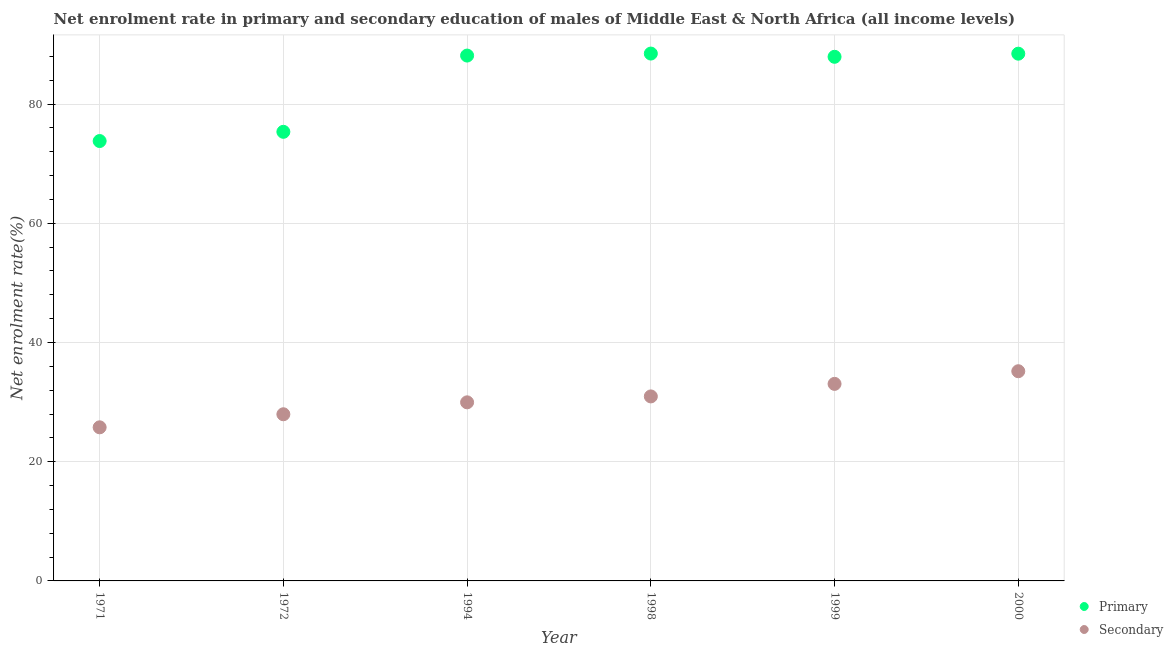What is the enrollment rate in secondary education in 1994?
Ensure brevity in your answer.  29.96. Across all years, what is the maximum enrollment rate in primary education?
Give a very brief answer. 88.48. Across all years, what is the minimum enrollment rate in secondary education?
Give a very brief answer. 25.77. In which year was the enrollment rate in secondary education maximum?
Your answer should be compact. 2000. What is the total enrollment rate in secondary education in the graph?
Your answer should be very brief. 182.89. What is the difference between the enrollment rate in secondary education in 1972 and that in 1998?
Provide a succinct answer. -2.99. What is the difference between the enrollment rate in primary education in 1994 and the enrollment rate in secondary education in 1998?
Offer a very short reply. 57.19. What is the average enrollment rate in secondary education per year?
Your answer should be compact. 30.48. In the year 2000, what is the difference between the enrollment rate in primary education and enrollment rate in secondary education?
Give a very brief answer. 53.27. What is the ratio of the enrollment rate in primary education in 1994 to that in 1998?
Your response must be concise. 1. Is the enrollment rate in primary education in 1971 less than that in 1999?
Ensure brevity in your answer.  Yes. What is the difference between the highest and the second highest enrollment rate in primary education?
Your answer should be very brief. 0.02. What is the difference between the highest and the lowest enrollment rate in primary education?
Offer a very short reply. 14.68. Is the enrollment rate in primary education strictly less than the enrollment rate in secondary education over the years?
Give a very brief answer. No. How many years are there in the graph?
Offer a terse response. 6. Does the graph contain any zero values?
Provide a succinct answer. No. Does the graph contain grids?
Your response must be concise. Yes. How are the legend labels stacked?
Give a very brief answer. Vertical. What is the title of the graph?
Your answer should be compact. Net enrolment rate in primary and secondary education of males of Middle East & North Africa (all income levels). What is the label or title of the Y-axis?
Give a very brief answer. Net enrolment rate(%). What is the Net enrolment rate(%) in Primary in 1971?
Offer a terse response. 73.8. What is the Net enrolment rate(%) of Secondary in 1971?
Offer a very short reply. 25.77. What is the Net enrolment rate(%) in Primary in 1972?
Ensure brevity in your answer.  75.35. What is the Net enrolment rate(%) of Secondary in 1972?
Give a very brief answer. 27.96. What is the Net enrolment rate(%) of Primary in 1994?
Make the answer very short. 88.14. What is the Net enrolment rate(%) of Secondary in 1994?
Provide a short and direct response. 29.96. What is the Net enrolment rate(%) in Primary in 1998?
Your answer should be very brief. 88.48. What is the Net enrolment rate(%) in Secondary in 1998?
Keep it short and to the point. 30.95. What is the Net enrolment rate(%) in Primary in 1999?
Keep it short and to the point. 87.93. What is the Net enrolment rate(%) in Secondary in 1999?
Your answer should be compact. 33.06. What is the Net enrolment rate(%) in Primary in 2000?
Make the answer very short. 88.46. What is the Net enrolment rate(%) in Secondary in 2000?
Your answer should be compact. 35.18. Across all years, what is the maximum Net enrolment rate(%) in Primary?
Offer a very short reply. 88.48. Across all years, what is the maximum Net enrolment rate(%) in Secondary?
Your answer should be compact. 35.18. Across all years, what is the minimum Net enrolment rate(%) in Primary?
Ensure brevity in your answer.  73.8. Across all years, what is the minimum Net enrolment rate(%) in Secondary?
Offer a very short reply. 25.77. What is the total Net enrolment rate(%) in Primary in the graph?
Offer a terse response. 502.16. What is the total Net enrolment rate(%) in Secondary in the graph?
Give a very brief answer. 182.89. What is the difference between the Net enrolment rate(%) in Primary in 1971 and that in 1972?
Offer a very short reply. -1.55. What is the difference between the Net enrolment rate(%) of Secondary in 1971 and that in 1972?
Offer a terse response. -2.19. What is the difference between the Net enrolment rate(%) of Primary in 1971 and that in 1994?
Your response must be concise. -14.34. What is the difference between the Net enrolment rate(%) in Secondary in 1971 and that in 1994?
Keep it short and to the point. -4.19. What is the difference between the Net enrolment rate(%) of Primary in 1971 and that in 1998?
Make the answer very short. -14.68. What is the difference between the Net enrolment rate(%) in Secondary in 1971 and that in 1998?
Provide a short and direct response. -5.18. What is the difference between the Net enrolment rate(%) in Primary in 1971 and that in 1999?
Ensure brevity in your answer.  -14.13. What is the difference between the Net enrolment rate(%) of Secondary in 1971 and that in 1999?
Your response must be concise. -7.29. What is the difference between the Net enrolment rate(%) of Primary in 1971 and that in 2000?
Give a very brief answer. -14.66. What is the difference between the Net enrolment rate(%) in Secondary in 1971 and that in 2000?
Provide a succinct answer. -9.41. What is the difference between the Net enrolment rate(%) of Primary in 1972 and that in 1994?
Ensure brevity in your answer.  -12.79. What is the difference between the Net enrolment rate(%) in Secondary in 1972 and that in 1994?
Your response must be concise. -2. What is the difference between the Net enrolment rate(%) of Primary in 1972 and that in 1998?
Provide a succinct answer. -13.13. What is the difference between the Net enrolment rate(%) of Secondary in 1972 and that in 1998?
Your answer should be compact. -2.99. What is the difference between the Net enrolment rate(%) in Primary in 1972 and that in 1999?
Provide a succinct answer. -12.59. What is the difference between the Net enrolment rate(%) of Secondary in 1972 and that in 1999?
Offer a very short reply. -5.1. What is the difference between the Net enrolment rate(%) of Primary in 1972 and that in 2000?
Make the answer very short. -13.11. What is the difference between the Net enrolment rate(%) in Secondary in 1972 and that in 2000?
Provide a succinct answer. -7.22. What is the difference between the Net enrolment rate(%) in Primary in 1994 and that in 1998?
Provide a succinct answer. -0.34. What is the difference between the Net enrolment rate(%) in Secondary in 1994 and that in 1998?
Make the answer very short. -0.99. What is the difference between the Net enrolment rate(%) of Primary in 1994 and that in 1999?
Provide a short and direct response. 0.21. What is the difference between the Net enrolment rate(%) in Secondary in 1994 and that in 1999?
Your response must be concise. -3.1. What is the difference between the Net enrolment rate(%) of Primary in 1994 and that in 2000?
Offer a very short reply. -0.32. What is the difference between the Net enrolment rate(%) in Secondary in 1994 and that in 2000?
Offer a terse response. -5.22. What is the difference between the Net enrolment rate(%) in Primary in 1998 and that in 1999?
Make the answer very short. 0.54. What is the difference between the Net enrolment rate(%) of Secondary in 1998 and that in 1999?
Make the answer very short. -2.1. What is the difference between the Net enrolment rate(%) of Primary in 1998 and that in 2000?
Offer a very short reply. 0.02. What is the difference between the Net enrolment rate(%) of Secondary in 1998 and that in 2000?
Ensure brevity in your answer.  -4.23. What is the difference between the Net enrolment rate(%) in Primary in 1999 and that in 2000?
Provide a succinct answer. -0.52. What is the difference between the Net enrolment rate(%) in Secondary in 1999 and that in 2000?
Give a very brief answer. -2.12. What is the difference between the Net enrolment rate(%) of Primary in 1971 and the Net enrolment rate(%) of Secondary in 1972?
Provide a succinct answer. 45.84. What is the difference between the Net enrolment rate(%) of Primary in 1971 and the Net enrolment rate(%) of Secondary in 1994?
Your response must be concise. 43.84. What is the difference between the Net enrolment rate(%) in Primary in 1971 and the Net enrolment rate(%) in Secondary in 1998?
Ensure brevity in your answer.  42.85. What is the difference between the Net enrolment rate(%) of Primary in 1971 and the Net enrolment rate(%) of Secondary in 1999?
Provide a short and direct response. 40.74. What is the difference between the Net enrolment rate(%) of Primary in 1971 and the Net enrolment rate(%) of Secondary in 2000?
Ensure brevity in your answer.  38.62. What is the difference between the Net enrolment rate(%) of Primary in 1972 and the Net enrolment rate(%) of Secondary in 1994?
Give a very brief answer. 45.38. What is the difference between the Net enrolment rate(%) in Primary in 1972 and the Net enrolment rate(%) in Secondary in 1998?
Make the answer very short. 44.39. What is the difference between the Net enrolment rate(%) in Primary in 1972 and the Net enrolment rate(%) in Secondary in 1999?
Keep it short and to the point. 42.29. What is the difference between the Net enrolment rate(%) in Primary in 1972 and the Net enrolment rate(%) in Secondary in 2000?
Your answer should be compact. 40.16. What is the difference between the Net enrolment rate(%) of Primary in 1994 and the Net enrolment rate(%) of Secondary in 1998?
Your response must be concise. 57.19. What is the difference between the Net enrolment rate(%) of Primary in 1994 and the Net enrolment rate(%) of Secondary in 1999?
Your answer should be compact. 55.08. What is the difference between the Net enrolment rate(%) in Primary in 1994 and the Net enrolment rate(%) in Secondary in 2000?
Give a very brief answer. 52.96. What is the difference between the Net enrolment rate(%) in Primary in 1998 and the Net enrolment rate(%) in Secondary in 1999?
Provide a succinct answer. 55.42. What is the difference between the Net enrolment rate(%) in Primary in 1998 and the Net enrolment rate(%) in Secondary in 2000?
Keep it short and to the point. 53.29. What is the difference between the Net enrolment rate(%) of Primary in 1999 and the Net enrolment rate(%) of Secondary in 2000?
Offer a terse response. 52.75. What is the average Net enrolment rate(%) of Primary per year?
Provide a short and direct response. 83.69. What is the average Net enrolment rate(%) of Secondary per year?
Your answer should be very brief. 30.48. In the year 1971, what is the difference between the Net enrolment rate(%) in Primary and Net enrolment rate(%) in Secondary?
Offer a terse response. 48.03. In the year 1972, what is the difference between the Net enrolment rate(%) of Primary and Net enrolment rate(%) of Secondary?
Provide a short and direct response. 47.39. In the year 1994, what is the difference between the Net enrolment rate(%) of Primary and Net enrolment rate(%) of Secondary?
Offer a terse response. 58.18. In the year 1998, what is the difference between the Net enrolment rate(%) in Primary and Net enrolment rate(%) in Secondary?
Your response must be concise. 57.52. In the year 1999, what is the difference between the Net enrolment rate(%) of Primary and Net enrolment rate(%) of Secondary?
Offer a very short reply. 54.88. In the year 2000, what is the difference between the Net enrolment rate(%) in Primary and Net enrolment rate(%) in Secondary?
Make the answer very short. 53.27. What is the ratio of the Net enrolment rate(%) of Primary in 1971 to that in 1972?
Make the answer very short. 0.98. What is the ratio of the Net enrolment rate(%) in Secondary in 1971 to that in 1972?
Your response must be concise. 0.92. What is the ratio of the Net enrolment rate(%) of Primary in 1971 to that in 1994?
Your response must be concise. 0.84. What is the ratio of the Net enrolment rate(%) in Secondary in 1971 to that in 1994?
Offer a terse response. 0.86. What is the ratio of the Net enrolment rate(%) of Primary in 1971 to that in 1998?
Give a very brief answer. 0.83. What is the ratio of the Net enrolment rate(%) of Secondary in 1971 to that in 1998?
Keep it short and to the point. 0.83. What is the ratio of the Net enrolment rate(%) of Primary in 1971 to that in 1999?
Offer a very short reply. 0.84. What is the ratio of the Net enrolment rate(%) of Secondary in 1971 to that in 1999?
Ensure brevity in your answer.  0.78. What is the ratio of the Net enrolment rate(%) of Primary in 1971 to that in 2000?
Provide a succinct answer. 0.83. What is the ratio of the Net enrolment rate(%) of Secondary in 1971 to that in 2000?
Ensure brevity in your answer.  0.73. What is the ratio of the Net enrolment rate(%) of Primary in 1972 to that in 1994?
Provide a short and direct response. 0.85. What is the ratio of the Net enrolment rate(%) in Secondary in 1972 to that in 1994?
Ensure brevity in your answer.  0.93. What is the ratio of the Net enrolment rate(%) in Primary in 1972 to that in 1998?
Provide a succinct answer. 0.85. What is the ratio of the Net enrolment rate(%) of Secondary in 1972 to that in 1998?
Ensure brevity in your answer.  0.9. What is the ratio of the Net enrolment rate(%) in Primary in 1972 to that in 1999?
Your response must be concise. 0.86. What is the ratio of the Net enrolment rate(%) in Secondary in 1972 to that in 1999?
Provide a succinct answer. 0.85. What is the ratio of the Net enrolment rate(%) of Primary in 1972 to that in 2000?
Give a very brief answer. 0.85. What is the ratio of the Net enrolment rate(%) in Secondary in 1972 to that in 2000?
Your answer should be very brief. 0.79. What is the ratio of the Net enrolment rate(%) in Primary in 1994 to that in 1998?
Make the answer very short. 1. What is the ratio of the Net enrolment rate(%) of Primary in 1994 to that in 1999?
Your response must be concise. 1. What is the ratio of the Net enrolment rate(%) of Secondary in 1994 to that in 1999?
Give a very brief answer. 0.91. What is the ratio of the Net enrolment rate(%) in Primary in 1994 to that in 2000?
Keep it short and to the point. 1. What is the ratio of the Net enrolment rate(%) of Secondary in 1994 to that in 2000?
Offer a terse response. 0.85. What is the ratio of the Net enrolment rate(%) of Secondary in 1998 to that in 1999?
Provide a short and direct response. 0.94. What is the ratio of the Net enrolment rate(%) of Secondary in 1998 to that in 2000?
Offer a terse response. 0.88. What is the ratio of the Net enrolment rate(%) of Primary in 1999 to that in 2000?
Offer a very short reply. 0.99. What is the ratio of the Net enrolment rate(%) of Secondary in 1999 to that in 2000?
Make the answer very short. 0.94. What is the difference between the highest and the second highest Net enrolment rate(%) of Primary?
Provide a short and direct response. 0.02. What is the difference between the highest and the second highest Net enrolment rate(%) of Secondary?
Provide a succinct answer. 2.12. What is the difference between the highest and the lowest Net enrolment rate(%) in Primary?
Ensure brevity in your answer.  14.68. What is the difference between the highest and the lowest Net enrolment rate(%) in Secondary?
Provide a short and direct response. 9.41. 